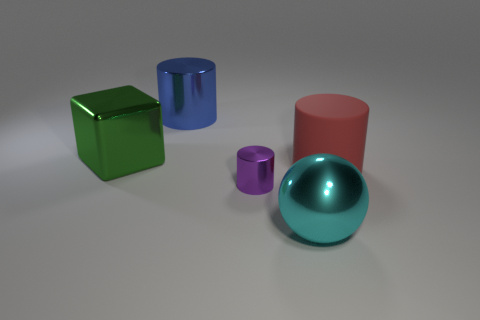Subtract all large cylinders. How many cylinders are left? 1 Add 5 blue blocks. How many objects exist? 10 Subtract all red cylinders. How many cylinders are left? 2 Subtract 1 balls. How many balls are left? 0 Subtract all brown cubes. Subtract all large shiny spheres. How many objects are left? 4 Add 3 metal cylinders. How many metal cylinders are left? 5 Add 5 large matte objects. How many large matte objects exist? 6 Subtract 0 gray balls. How many objects are left? 5 Subtract all spheres. How many objects are left? 4 Subtract all green balls. Subtract all yellow cylinders. How many balls are left? 1 